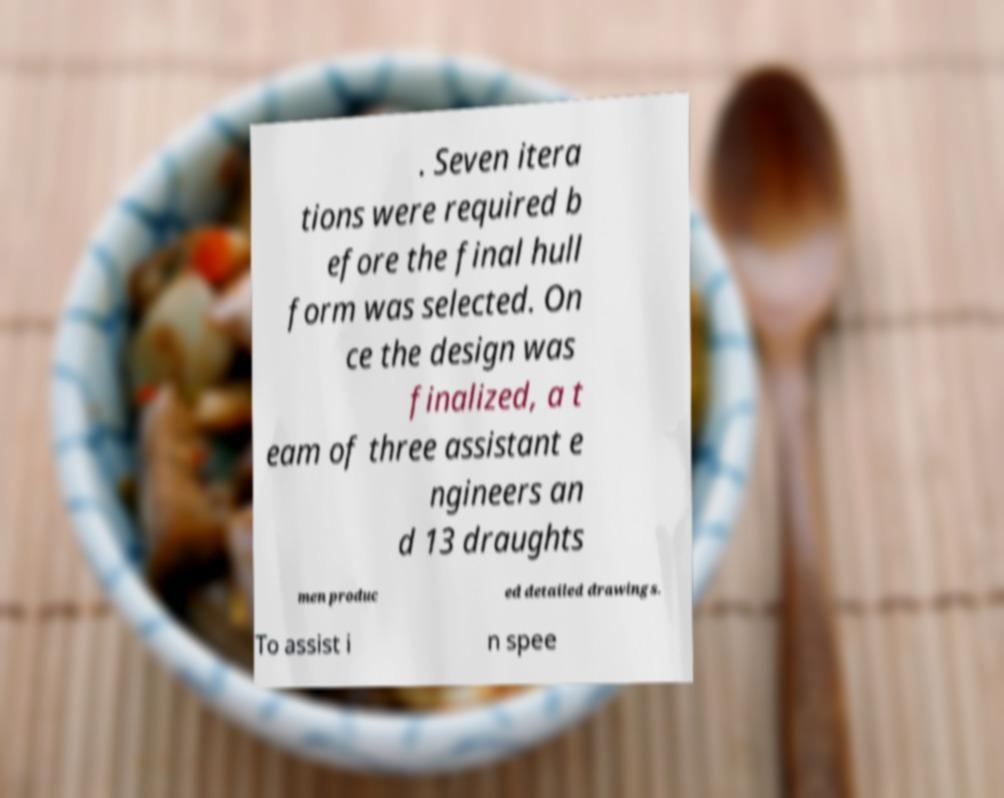Please identify and transcribe the text found in this image. . Seven itera tions were required b efore the final hull form was selected. On ce the design was finalized, a t eam of three assistant e ngineers an d 13 draughts men produc ed detailed drawings. To assist i n spee 